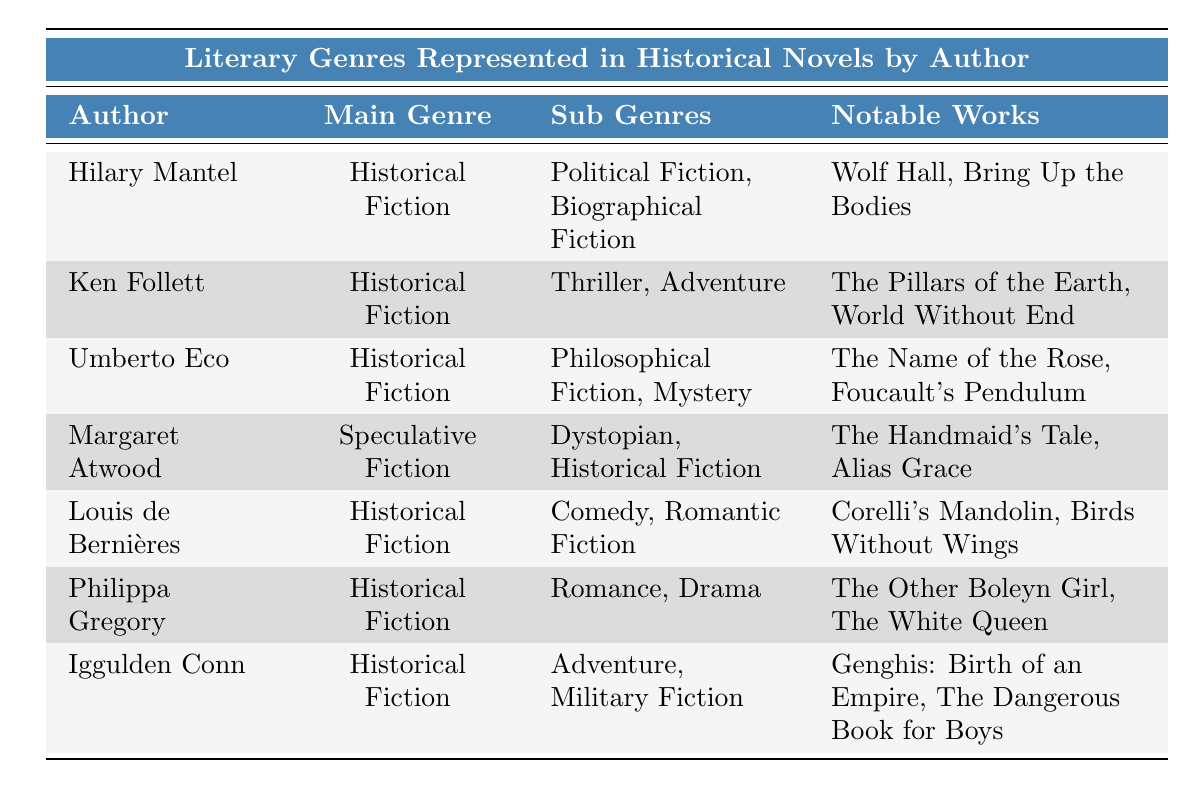What is the main genre of Hilary Mantel's works? The main genre listed for Hilary Mantel in the table is "Historical Fiction."
Answer: Historical Fiction Which notable work belongs to Ken Follett? The table indicates that notable works by Ken Follett include "The Pillars of the Earth" and "World Without End." Thus, one notable work is "The Pillars of the Earth."
Answer: The Pillars of the Earth How many authors have "Historical Fiction" listed as their main genre? By counting the rows in the table, six authors are identified with "Historical Fiction" as their main genre: Hilary Mantel, Ken Follett, Umberto Eco, Louis de Bernières, Philippa Gregory, and Iggulden Conn.
Answer: 6 Does Margaret Atwood have "Romance" as a sub-genre in her works? According to the table, Margaret Atwood's main genre is "Speculative Fiction," and her sub-genres are "Dystopian" and "Historical Fiction." Therefore, she does not have "Romance" listed as a sub-genre.
Answer: No Which author has the most diverse sub-genres listed? The author with the most sub-genres listed is Umberto Eco, who has "Philosophical Fiction" and "Mystery" for a total of two sub-genres; however, Ken Follett and others also have two sub-genres. Therefore, the authors with the most diverse sub-genres are Ken Follett, Umberto Eco, and others like Louis de Bernières and Philippa Gregory with two each. There are no authors with more than two.
Answer: Multiple authors have equal diversity What is the relationship between Ken Follett's sub-genres and his notable works? Ken Follett's sub-genres are "Thriller" and "Adventure." The notable works associated with him are "The Pillars of the Earth" and "World Without End," which can be categorized under those sub-genres as they both incorporate thrilling adventures. This illustrates how his writings align with the narrative styles of his chosen genres.
Answer: They align well Which author predominantly writes Comedy within their works? The table lists Louis de Bernières with "Comedy" as one of his sub-genres, indicating his works prominently include elements of comedy.
Answer: Louis de Bernières What are all the sub-genres represented by the authors in the table? By looking at the table, the sub-genres represented are: Political Fiction, Biographical Fiction, Thriller, Adventure, Philosophical Fiction, Mystery, Dystopian, Comedy, Romantic Fiction, Romance, and Drama. Count among all entries gives a total of 11 sub-genres.
Answer: 11 sub-genres Which author's notable works also belong to the Historical Fiction genre? Margaret Atwood's notable works such as "The Handmaid's Tale" and "Alias Grace" include "Historical Fiction" as one of her sub-genres, indicating they relate to the genre despite her main genre being "Speculative Fiction."
Answer: Margaret Atwood 